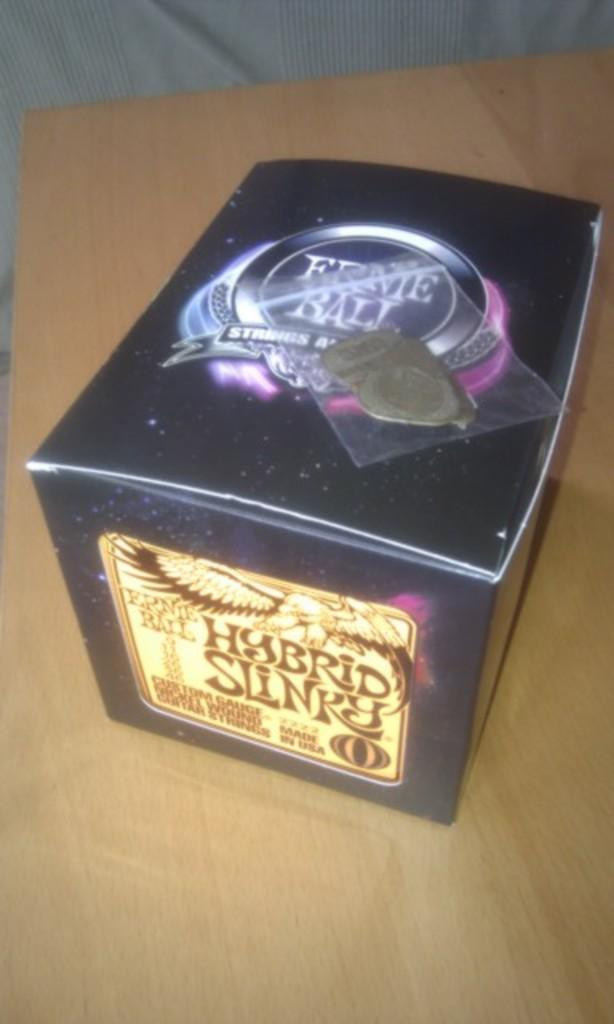<image>
Present a compact description of the photo's key features. Guitar picks are on a box of Hybrid Slinky guitar strings. 